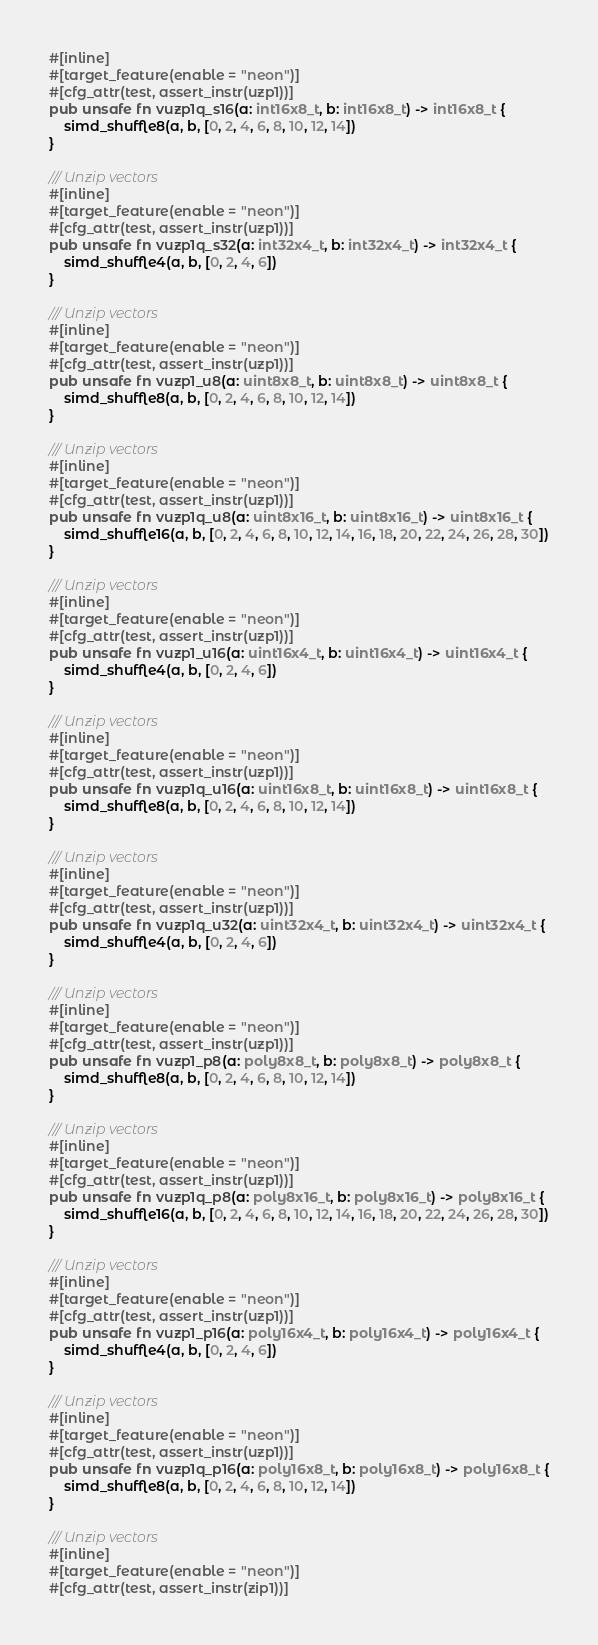<code> <loc_0><loc_0><loc_500><loc_500><_Rust_>#[inline]
#[target_feature(enable = "neon")]
#[cfg_attr(test, assert_instr(uzp1))]
pub unsafe fn vuzp1q_s16(a: int16x8_t, b: int16x8_t) -> int16x8_t {
    simd_shuffle8(a, b, [0, 2, 4, 6, 8, 10, 12, 14])
}

/// Unzip vectors
#[inline]
#[target_feature(enable = "neon")]
#[cfg_attr(test, assert_instr(uzp1))]
pub unsafe fn vuzp1q_s32(a: int32x4_t, b: int32x4_t) -> int32x4_t {
    simd_shuffle4(a, b, [0, 2, 4, 6])
}

/// Unzip vectors
#[inline]
#[target_feature(enable = "neon")]
#[cfg_attr(test, assert_instr(uzp1))]
pub unsafe fn vuzp1_u8(a: uint8x8_t, b: uint8x8_t) -> uint8x8_t {
    simd_shuffle8(a, b, [0, 2, 4, 6, 8, 10, 12, 14])
}

/// Unzip vectors
#[inline]
#[target_feature(enable = "neon")]
#[cfg_attr(test, assert_instr(uzp1))]
pub unsafe fn vuzp1q_u8(a: uint8x16_t, b: uint8x16_t) -> uint8x16_t {
    simd_shuffle16(a, b, [0, 2, 4, 6, 8, 10, 12, 14, 16, 18, 20, 22, 24, 26, 28, 30])
}

/// Unzip vectors
#[inline]
#[target_feature(enable = "neon")]
#[cfg_attr(test, assert_instr(uzp1))]
pub unsafe fn vuzp1_u16(a: uint16x4_t, b: uint16x4_t) -> uint16x4_t {
    simd_shuffle4(a, b, [0, 2, 4, 6])
}

/// Unzip vectors
#[inline]
#[target_feature(enable = "neon")]
#[cfg_attr(test, assert_instr(uzp1))]
pub unsafe fn vuzp1q_u16(a: uint16x8_t, b: uint16x8_t) -> uint16x8_t {
    simd_shuffle8(a, b, [0, 2, 4, 6, 8, 10, 12, 14])
}

/// Unzip vectors
#[inline]
#[target_feature(enable = "neon")]
#[cfg_attr(test, assert_instr(uzp1))]
pub unsafe fn vuzp1q_u32(a: uint32x4_t, b: uint32x4_t) -> uint32x4_t {
    simd_shuffle4(a, b, [0, 2, 4, 6])
}

/// Unzip vectors
#[inline]
#[target_feature(enable = "neon")]
#[cfg_attr(test, assert_instr(uzp1))]
pub unsafe fn vuzp1_p8(a: poly8x8_t, b: poly8x8_t) -> poly8x8_t {
    simd_shuffle8(a, b, [0, 2, 4, 6, 8, 10, 12, 14])
}

/// Unzip vectors
#[inline]
#[target_feature(enable = "neon")]
#[cfg_attr(test, assert_instr(uzp1))]
pub unsafe fn vuzp1q_p8(a: poly8x16_t, b: poly8x16_t) -> poly8x16_t {
    simd_shuffle16(a, b, [0, 2, 4, 6, 8, 10, 12, 14, 16, 18, 20, 22, 24, 26, 28, 30])
}

/// Unzip vectors
#[inline]
#[target_feature(enable = "neon")]
#[cfg_attr(test, assert_instr(uzp1))]
pub unsafe fn vuzp1_p16(a: poly16x4_t, b: poly16x4_t) -> poly16x4_t {
    simd_shuffle4(a, b, [0, 2, 4, 6])
}

/// Unzip vectors
#[inline]
#[target_feature(enable = "neon")]
#[cfg_attr(test, assert_instr(uzp1))]
pub unsafe fn vuzp1q_p16(a: poly16x8_t, b: poly16x8_t) -> poly16x8_t {
    simd_shuffle8(a, b, [0, 2, 4, 6, 8, 10, 12, 14])
}

/// Unzip vectors
#[inline]
#[target_feature(enable = "neon")]
#[cfg_attr(test, assert_instr(zip1))]</code> 